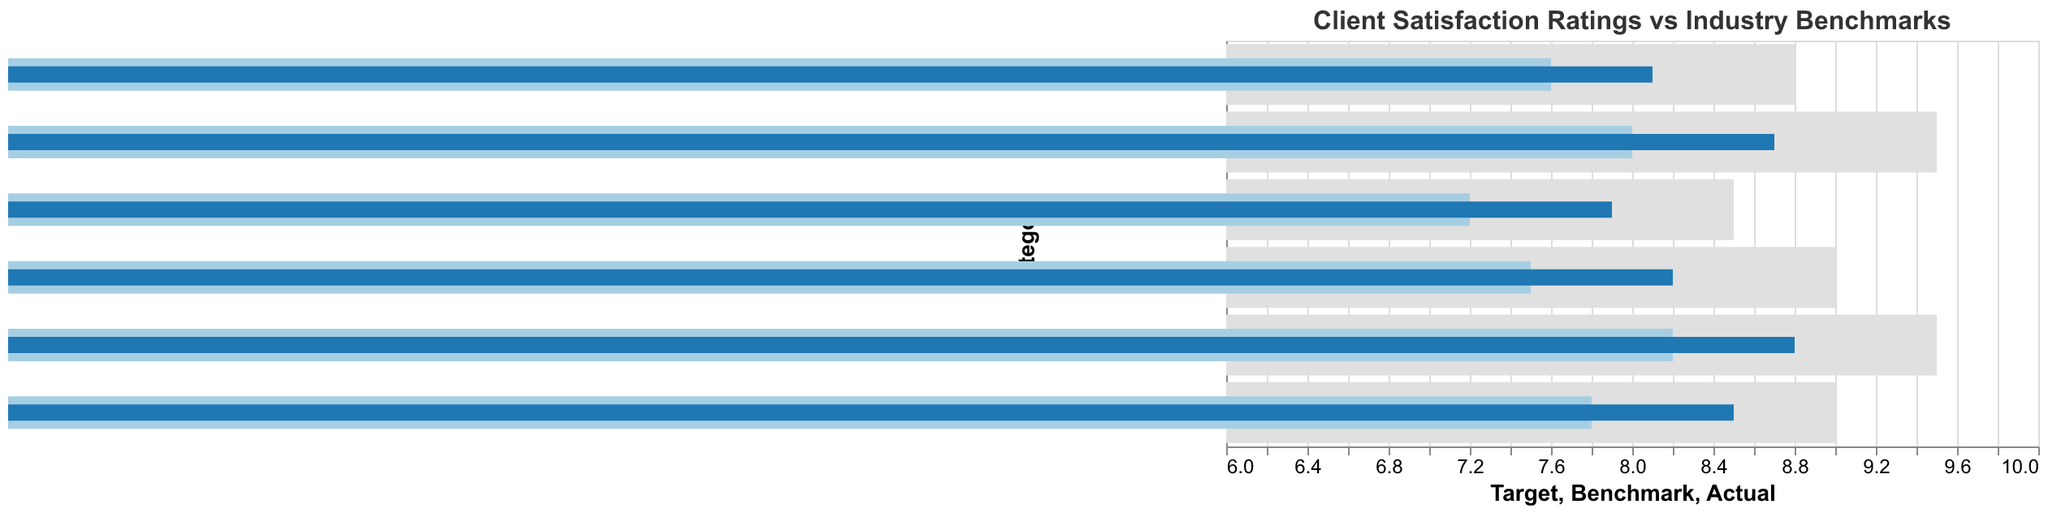What's the title of the chart? The title of the chart is displayed at the top of the figure.
Answer: Client Satisfaction Ratings vs Industry Benchmarks What category has the highest actual satisfaction rating? Look at the bar representing the actual satisfaction ratings and identify the tallest bar.
Answer: Responsiveness What is the difference between the actual satisfaction rating and the benchmark rating for Load Speed? Subtract the benchmark rating from the actual satisfaction rating for Load Speed (8.7 - 8.0).
Answer: 0.7 For how many categories does the actual rating exceed the benchmark rating? Compare the actual and benchmark ratings for each category to count how many times the actual rating is higher.
Answer: All categories Which category has the smallest gap between the actual rating and the target rating? Calculate the absolute differences between the actual ratings and target ratings for each category and find the smallest value.
Answer: Navigation Ease What is the overall trend of actual satisfaction ratings compared to benchmarks? Compare the actual ratings with benchmark ratings generally, noticing if actual ratings are typically higher, lower, or the same.
Answer: Higher What category falls shortest of its target rating? Calculate the difference between the target rating and the actual rating for each category and identify the largest gap.
Answer: Load Speed How does the ‘Visual Appeal’ category’s actual satisfaction rating compare to its benchmark and target ratings? Look at the actual, benchmark, and target ratings for Visual Appeal and compare them. The actual rating is 8.5, the benchmark is 7.8, and the target is 9.0.
Answer: Better than the benchmark but below the target What is the average of the actual satisfaction ratings across all categories? Sum the actual ratings for all categories and then divide by the number of categories: (8.2 + 8.7 + 7.9 + 8.5 + 8.8 + 8.1) / 6.
Answer: 8.37 Which categories exceed their targets? Compare the actual ratings to the target ratings for each category to see if any actual ratings are higher.
Answer: None 